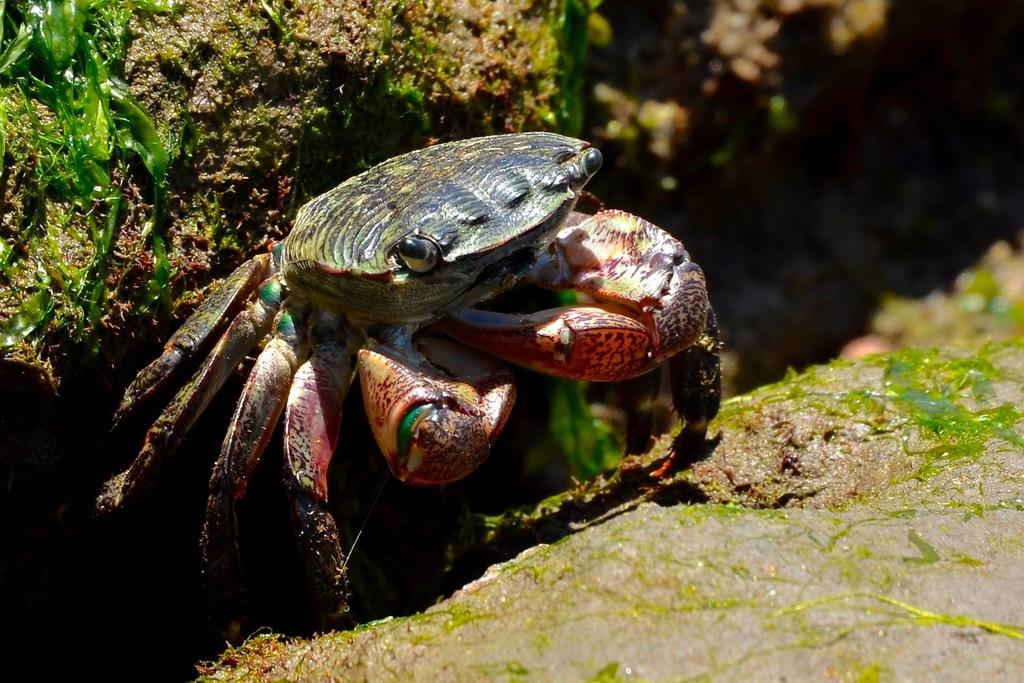What type of animal is in the image? There is a crab in the image. What colors can be seen on the crab? The crab has red, green, and black colors. What colors are present in the background of the image? The background of the image has green and brown colors. What type of machine is depicted in the image? There is no machine present in the image; it features a crab with red, green, and black colors against a green and brown background. How does the crab feel about being in the image? The crab is an inanimate object and does not have feelings, so it cannot feel anything about being in the image. 